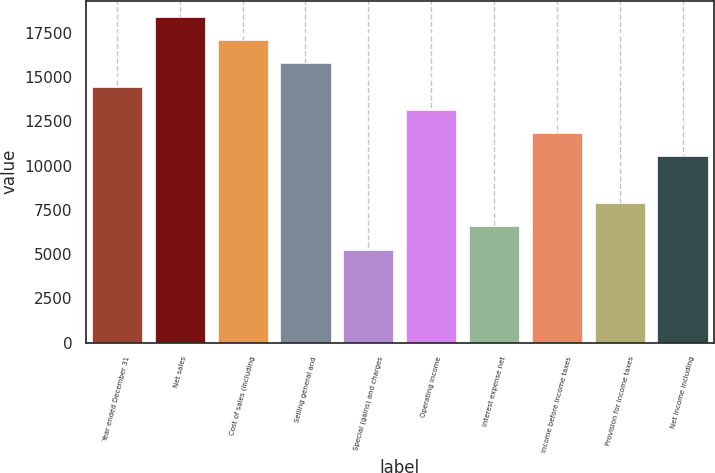<chart> <loc_0><loc_0><loc_500><loc_500><bar_chart><fcel>Year ended December 31<fcel>Net sales<fcel>Cost of sales (including<fcel>Selling general and<fcel>Special (gains) and charges<fcel>Operating income<fcel>Interest expense net<fcel>Income before income taxes<fcel>Provision for income taxes<fcel>Net income including<nl><fcel>14468<fcel>18413.4<fcel>17098.2<fcel>15783.1<fcel>5261.98<fcel>13152.8<fcel>6577.12<fcel>11837.7<fcel>7892.26<fcel>10522.5<nl></chart> 